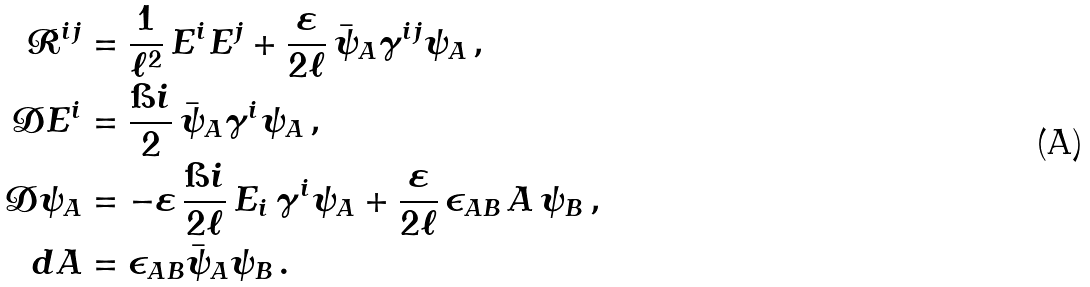Convert formula to latex. <formula><loc_0><loc_0><loc_500><loc_500>\mathcal { R } ^ { i j } & = \frac { 1 } { \ell ^ { 2 } } \, E ^ { i } E ^ { j } + \frac { \varepsilon } { 2 \ell } \, \bar { \psi } _ { A } \gamma ^ { i j } \psi _ { A } \, , \\ { \mathcal { D } } E ^ { i } & = \frac { \i i } { 2 } \, \bar { \psi } _ { A } \gamma ^ { i } \psi _ { A } \, , \\ { \mathcal { D } } \psi _ { A } & = - \varepsilon \, \frac { \i i } { 2 \ell } \, E _ { i } \, \gamma ^ { i } \psi _ { A } + \frac { \varepsilon } { 2 \ell } \, \epsilon _ { A B } \, A \, { \psi } _ { B } \, , \\ d A & = \epsilon _ { A B } \bar { \psi } _ { A } \psi _ { B } \, .</formula> 